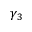Convert formula to latex. <formula><loc_0><loc_0><loc_500><loc_500>\gamma _ { 3 }</formula> 